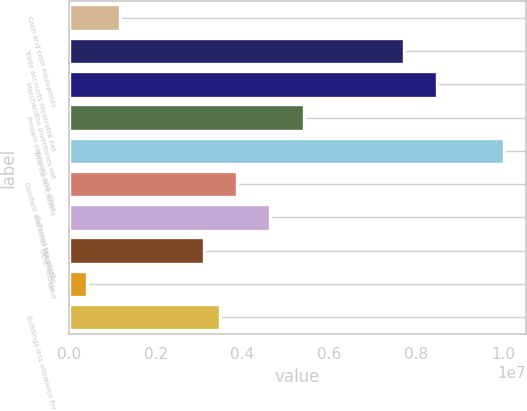<chart> <loc_0><loc_0><loc_500><loc_500><bar_chart><fcel>Cash and cash equivalents<fcel>Trade accounts receivable net<fcel>Merchandise inventories net<fcel>Prepaid expenses and other<fcel>Total current assets<fcel>Goodwill and other intangible<fcel>Deferred tax asset<fcel>Other assets<fcel>Land<fcel>Buildings less allowance for<nl><fcel>1.17871e+06<fcel>7.71816e+06<fcel>8.4875e+06<fcel>5.41011e+06<fcel>1.00262e+07<fcel>3.87142e+06<fcel>4.64077e+06<fcel>3.10207e+06<fcel>409358<fcel>3.48675e+06<nl></chart> 